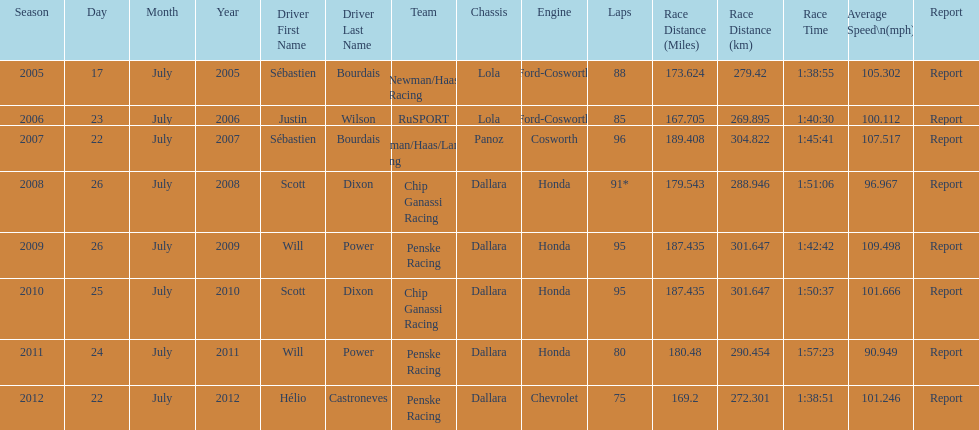What is the least amount of laps completed? 75. Could you parse the entire table? {'header': ['Season', 'Day', 'Month', 'Year', 'Driver First Name', 'Driver Last Name', 'Team', 'Chassis', 'Engine', 'Laps', 'Race Distance (Miles)', 'Race Distance (km)', 'Race Time', 'Average Speed\\n(mph)', 'Report'], 'rows': [['2005', '17', 'July', '2005', 'Sébastien', 'Bourdais', 'Newman/Haas Racing', 'Lola', 'Ford-Cosworth', '88', '173.624', '279.42', '1:38:55', '105.302', 'Report'], ['2006', '23', 'July', '2006', 'Justin', 'Wilson', 'RuSPORT', 'Lola', 'Ford-Cosworth', '85', '167.705', '269.895', '1:40:30', '100.112', 'Report'], ['2007', '22', 'July', '2007', 'Sébastien', 'Bourdais', 'Newman/Haas/Lanigan Racing', 'Panoz', 'Cosworth', '96', '189.408', '304.822', '1:45:41', '107.517', 'Report'], ['2008', '26', 'July', '2008', 'Scott', 'Dixon', 'Chip Ganassi Racing', 'Dallara', 'Honda', '91*', '179.543', '288.946', '1:51:06', '96.967', 'Report'], ['2009', '26', 'July', '2009', 'Will', 'Power', 'Penske Racing', 'Dallara', 'Honda', '95', '187.435', '301.647', '1:42:42', '109.498', 'Report'], ['2010', '25', 'July', '2010', 'Scott', 'Dixon', 'Chip Ganassi Racing', 'Dallara', 'Honda', '95', '187.435', '301.647', '1:50:37', '101.666', 'Report'], ['2011', '24', 'July', '2011', 'Will', 'Power', 'Penske Racing', 'Dallara', 'Honda', '80', '180.48', '290.454', '1:57:23', '90.949', 'Report'], ['2012', '22', 'July', '2012', 'Hélio', 'Castroneves', 'Penske Racing', 'Dallara', 'Chevrolet', '75', '169.2', '272.301', '1:38:51', '101.246', 'Report']]} 